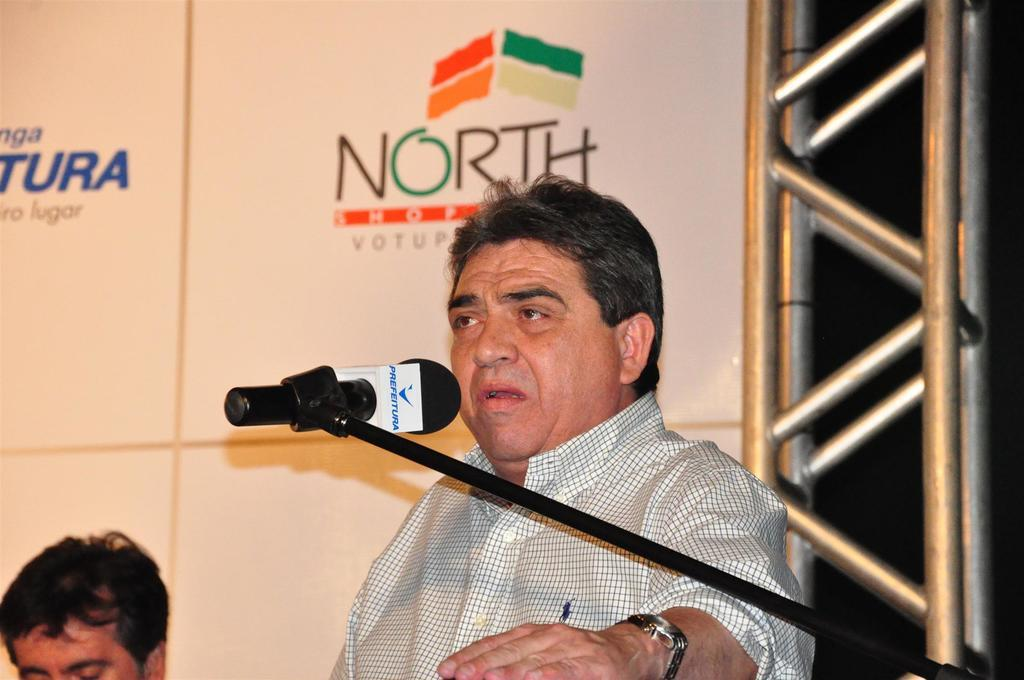What is the main subject of the image? There is a person in the center of the image. What is the person in the image doing? The person is talking into a microphone. Can you describe another person visible in the image? There is a person's head visible to the left side of the image. How many islands can be seen in the image? There are no islands present in the image. What type of salt is being used by the person in the image? There is no salt visible or mentioned in the image. 